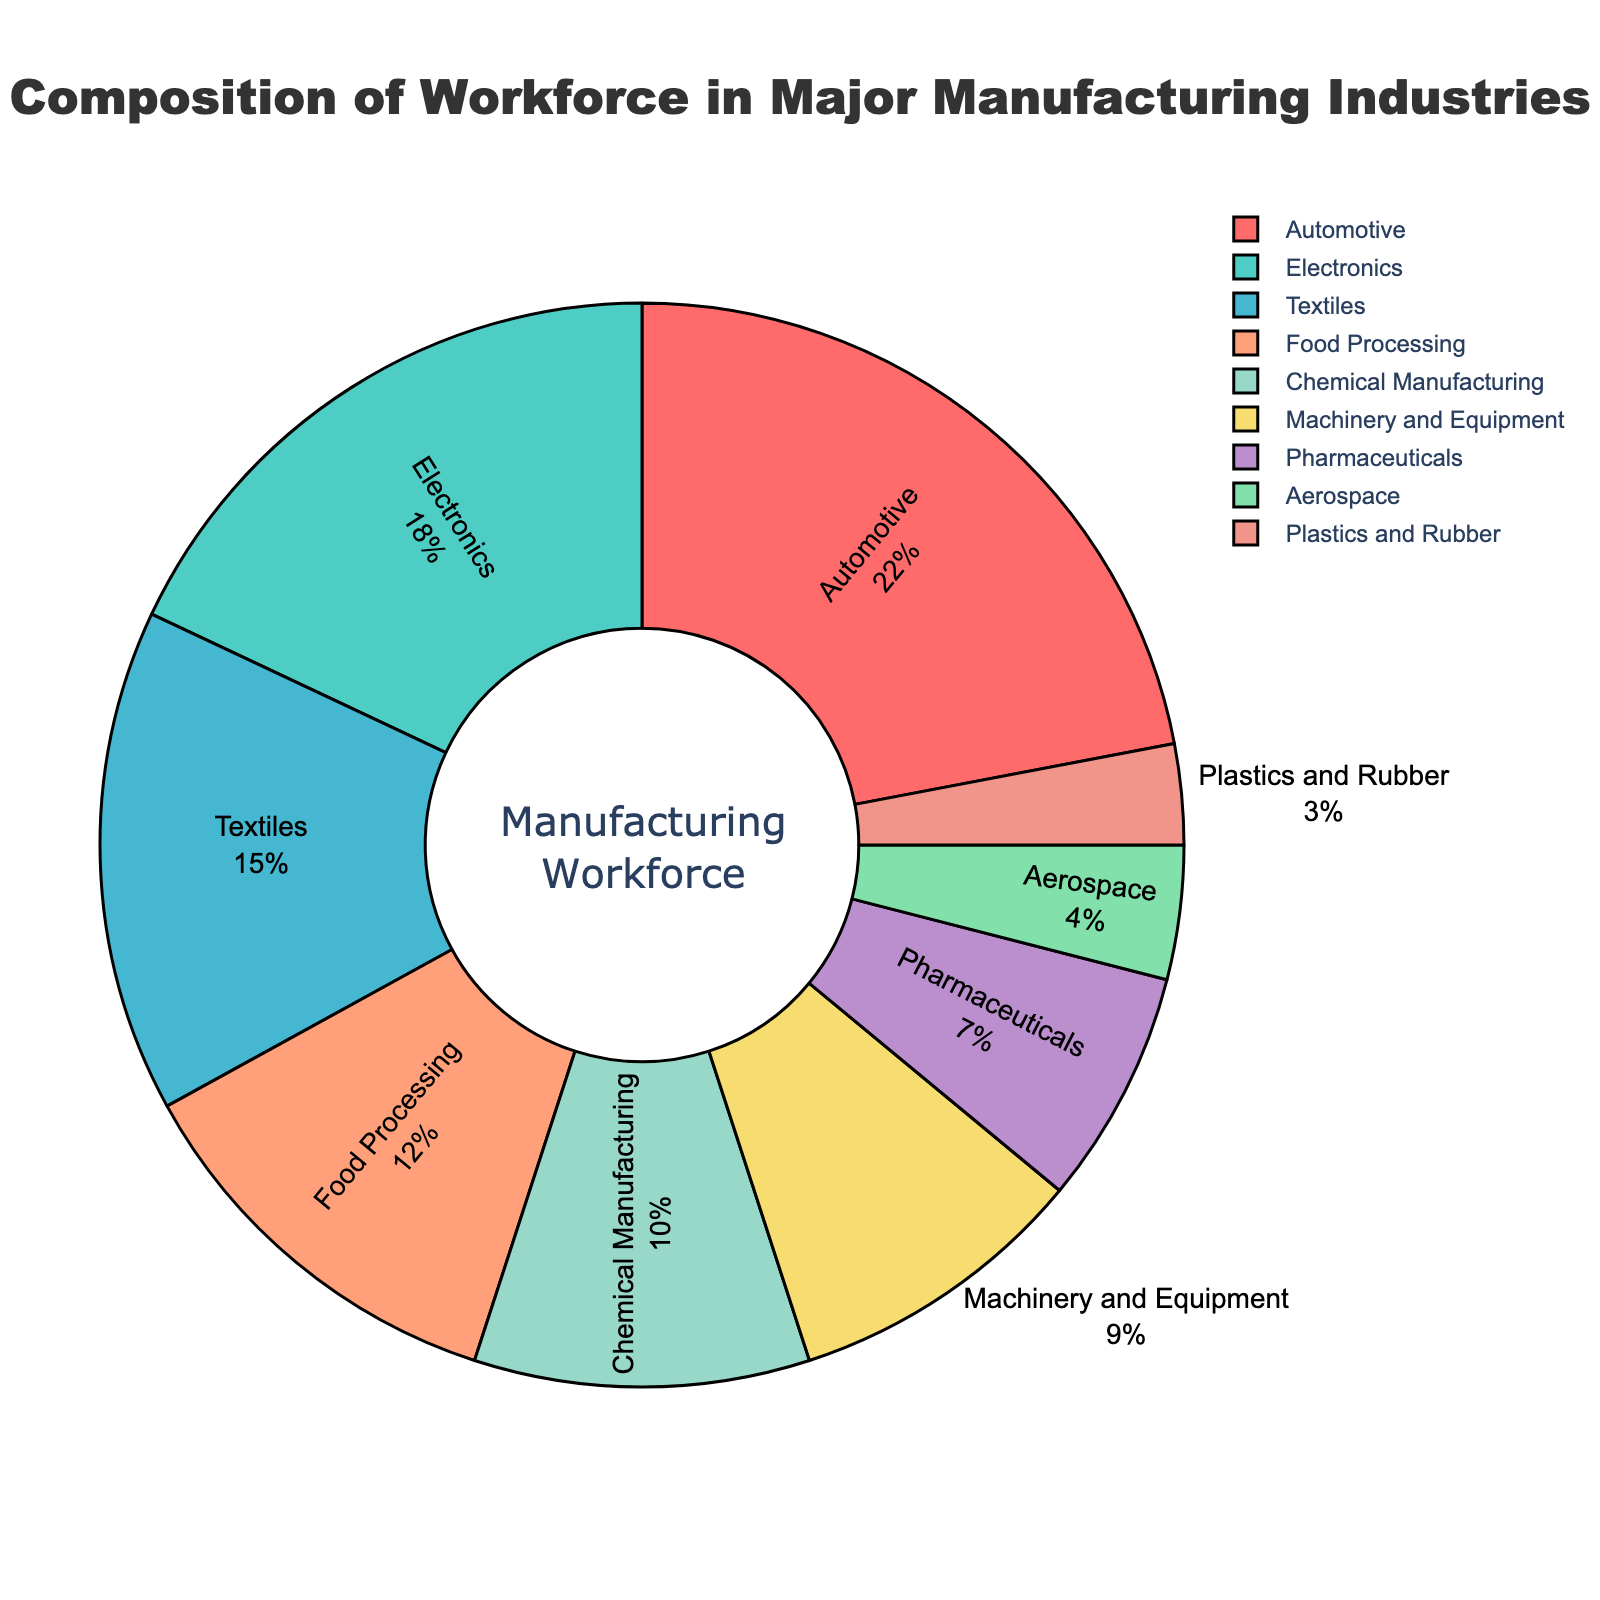what percentage of the workforce is in the Automotive and Textile industries combined? To find the combined percentage, add the percentage of the workforce in the Automotive industry (22%) and the Textiles industry (15%). The calculation is 22% + 15% = 37%.
Answer: 37% Which industry employs fewer people: Pharmaceuticals or Aerospace? Comparing the percentages of the workforce in Pharmaceuticals (7%) and Aerospace (4%), Aerospace employs fewer people.
Answer: Aerospace How much larger is the workforce in the Electronics industry compared to the Plastics and Rubber industry? Subtract the percentage of the workforce in the Plastics and Rubber industry (3%) from the percentage in the Electronics industry (18%). The calculation is 18% - 3% = 15%.
Answer: 15% If you combine the workforce in Machinery and Equipment with the workforce in Chemical Manufacturing, will the total workforce exceed the Electronics industry? Adding the percentages of the workforce in Machinery and Equipment (9%) and Chemical Manufacturing (10%) gives 9% + 10% = 19%. The Electronics industry workforce is 18%, so 19% is greater than 18%.
Answer: Yes Which industry sector represents the smallest portion of the workforce? Referring to the pie chart, Plastics and Rubber represent the smallest portion of the workforce with 3%.
Answer: Plastics and Rubber What is the average percentage of the workforce in the Aerospace, Food Processing, and Chemical Manufacturing industries? Add the percentages for Aerospace (4%), Food Processing (12%), and Chemical Manufacturing (10%) and divide by the number of industries: (4% + 12% + 10%) / 3 = 26% / 3 ≈ 8.67%.
Answer: 8.67% Is the percentage of the workforce in the Pharmaceuticals industry greater than that in the Aerospace and Plastics and Rubber industries combined? Add the percentages for Aerospace (4%) and Plastics and Rubber (3%) which equals 7%. The Pharmaceuticals industry also has 7%, so they are equal.
Answer: No What color represents the Automotive industry in the pie chart? The color representing the Automotive industry in the pie chart is visually seen as red.
Answer: Red How much more workforce does the Textiles industry have compared to the Chemical Manufacturing industry? Subtract the percentage of the workforce in the Chemical Manufacturing industry (10%) from the Textiles industry (15%). The calculation is 15% - 10% = 5%.
Answer: 5% Which two industries together account for more than 30% of the workforce? Add the percentages of different industries, and find that Automotive (22%) and Electronics (18%) together make 40%, which is more than 30%.
Answer: Automotive and Electronics 